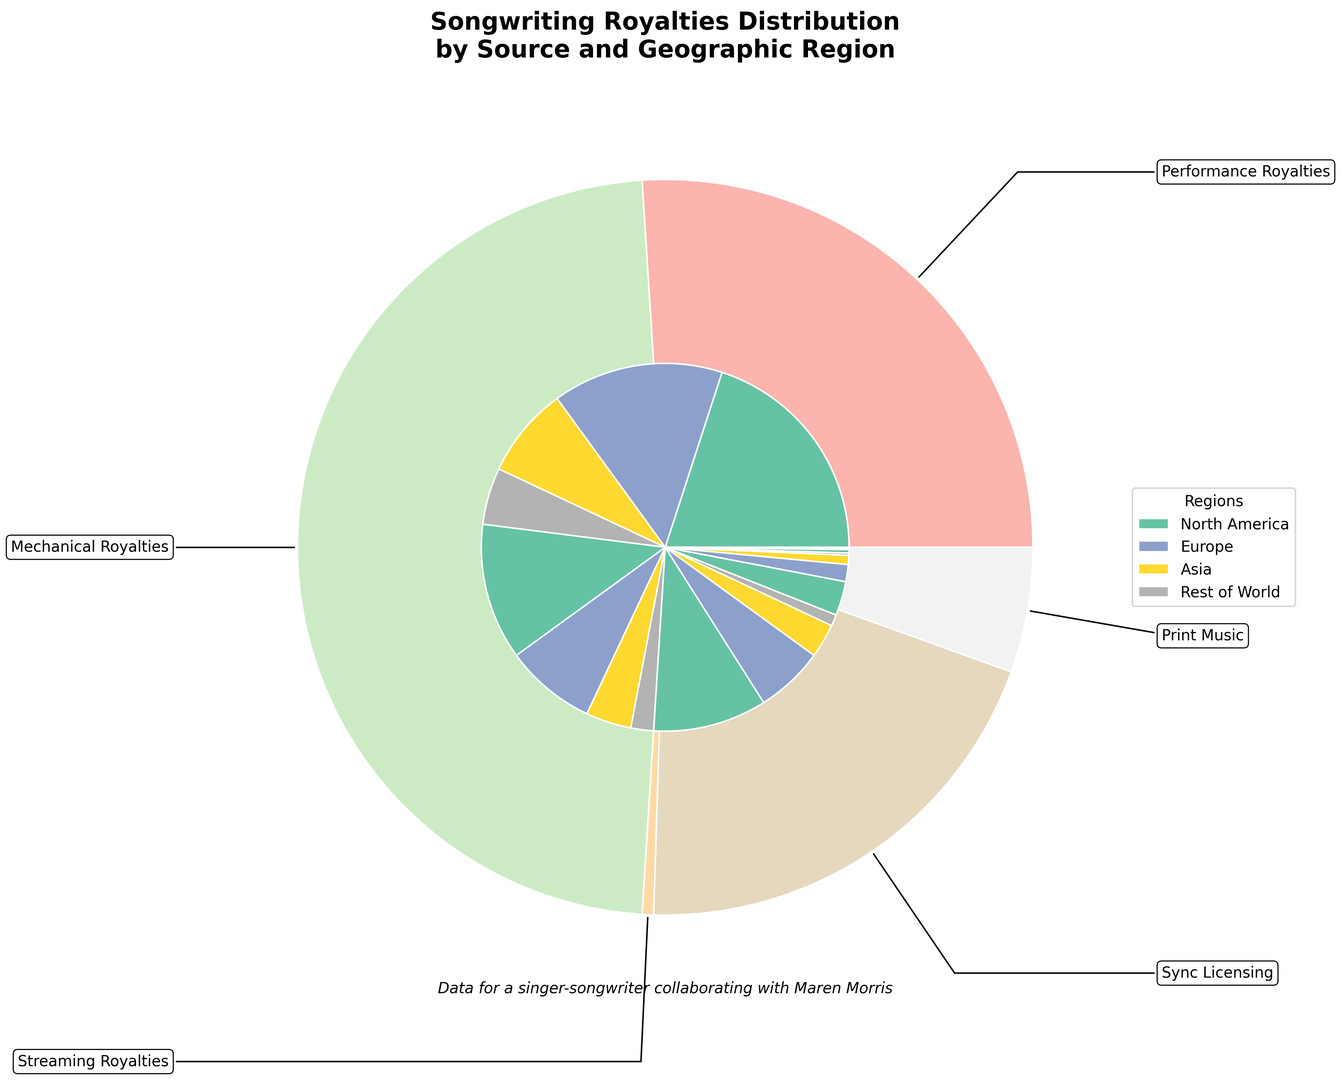Which region has the highest percentage of Performance Royalties? By examining the figure, we see that the North America section of the Performance Royalties segment is the largest, indicating the highest percentage.
Answer: North America What is the combined percentage of Streaming Royalties in Europe and Asia? Referring to the inner pie chart, Streaming Royalties in Europe show 6%, and in Asia, it is 3%. Adding these together gives us 6% + 3% = 9%.
Answer: 9% How does the percentage of Mechanical Royalties in North America compare to Europe? From the visual distribution, North America has 12% in Mechanical Royalties, while Europe has 8%. Thus, North America has a higher percentage than Europe.
Answer: North America What's the total percentage of royalties coming from Sync Licensing across all regions? Summing the values for Sync Licensing across all regions: North America (3%) + Europe (1.5%) + Asia (0.8%) + Rest of World (0.2%) = 5.5%.
Answer: 5.5% Which source of royalties has the smallest contribution in Asia? Visual inspection of the inner pie chart for Asia reveals that Print Music has the smallest segment with 0.05%.
Answer: Print Music Are Mechanical Royalties in North America greater than the combined Mechanical royalties in Asia and Rest of World? Mechanical Royalties in North America are 12%, while in Asia they are 4% and in Rest of World, 2%. Combining Asia and Rest of World gives 4% + 2% = 6%, which is less than North America's 12%.
Answer: Yes Which region contributes the least to Sync Licensing royalties? Looking at the Sync Licensing portions, the smallest region is Rest of World with 0.2%.
Answer: Rest of World How much percentage more does Performance Royalties in North America contribute compared to Print Music in North America? Performance Royalties in North America is 20%, and Print Music in North America is 0.3%. The difference is 20% - 0.3% = 19.7%.
Answer: 19.7% Which region has the second-highest percentage for Streaming Royalties? Referring to the inner segments of Streaming Royalties, Europe has the second-highest percentage at 6%, following North America at 10%.
Answer: Europe What is the average percentage of Performance Royalties across all regions? Summing the percentages of Performance Royalties across regions: 20% (North America) + 15% (Europe) + 8% (Asia) + 5% (Rest of World) = 48%. The average is 48% / 4 = 12%.
Answer: 12% 